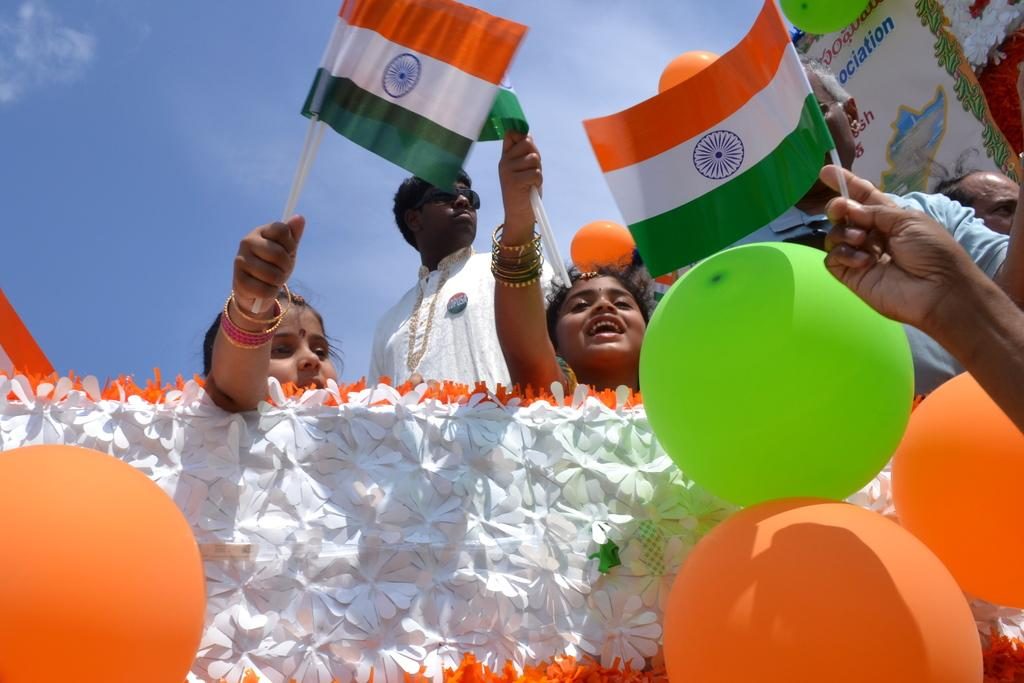What objects are present in the image that are typically associated with celebrations? There are balloons and a banner in the image, which are commonly used for celebrations. What type of flowers can be seen in the image? There are white color flowers in the image. What are the people in the image doing? The people in the image are holding flags. What can be seen in the background of the image? The sky is visible in the background of the image. Where are the dolls placed in the image? There are no dolls present in the image. What type of cemetery can be seen in the image? There is no cemetery present in the image. 